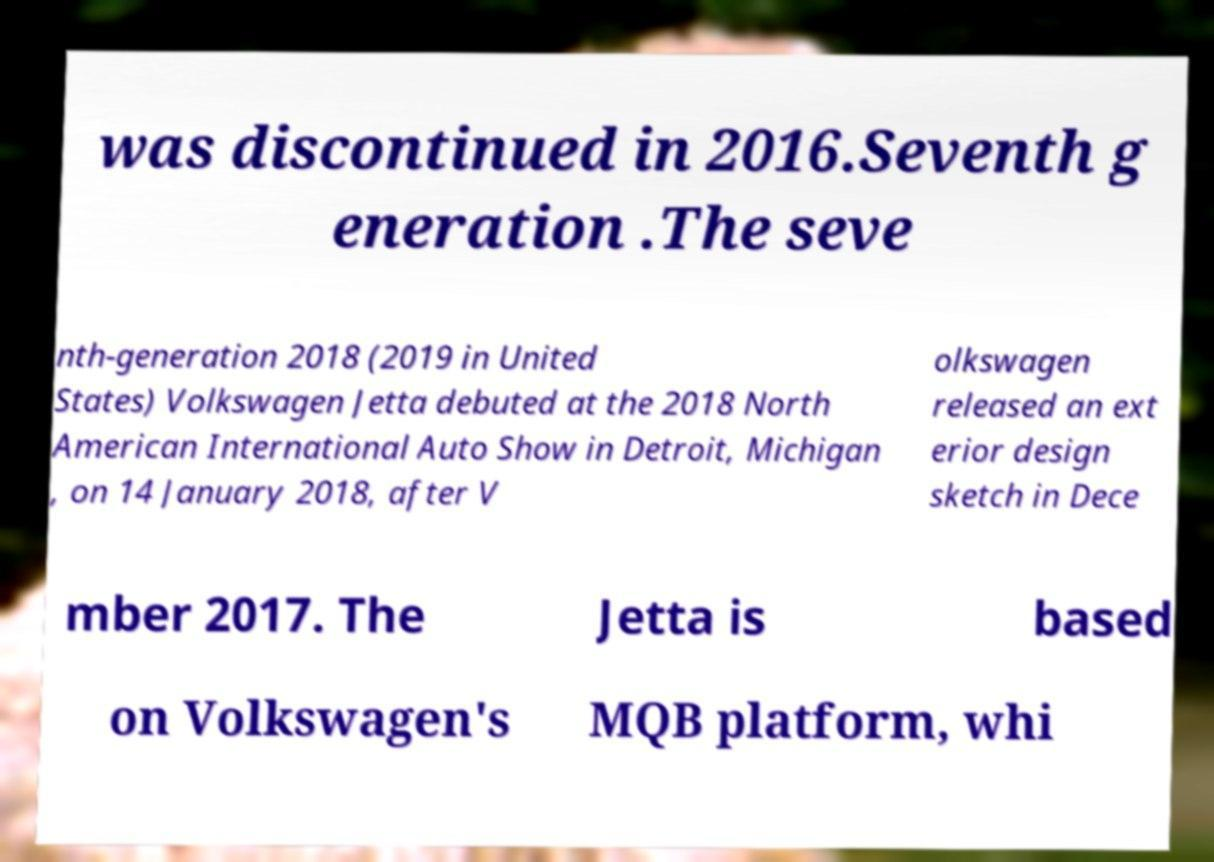Can you accurately transcribe the text from the provided image for me? was discontinued in 2016.Seventh g eneration .The seve nth-generation 2018 (2019 in United States) Volkswagen Jetta debuted at the 2018 North American International Auto Show in Detroit, Michigan , on 14 January 2018, after V olkswagen released an ext erior design sketch in Dece mber 2017. The Jetta is based on Volkswagen's MQB platform, whi 